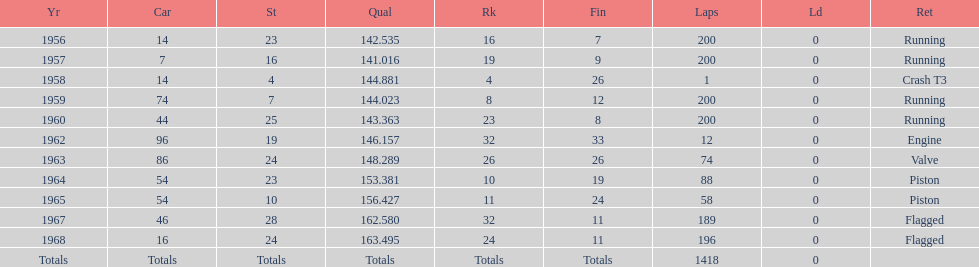What is the larger laps between 1963 or 1968 1968. 